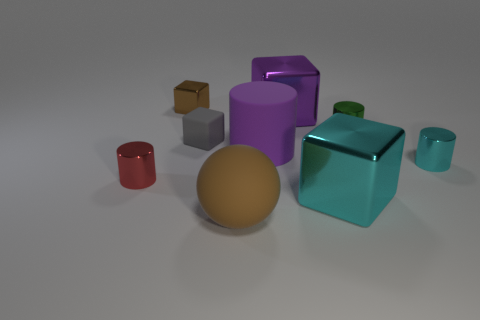Subtract all tiny brown blocks. How many blocks are left? 3 Subtract all red cylinders. How many cylinders are left? 3 Subtract 1 cylinders. How many cylinders are left? 3 Add 1 small green shiny cylinders. How many objects exist? 10 Subtract 0 brown cylinders. How many objects are left? 9 Subtract all cubes. How many objects are left? 5 Subtract all yellow cylinders. Subtract all yellow cubes. How many cylinders are left? 4 Subtract all gray balls. How many purple cylinders are left? 1 Subtract all tiny gray cubes. Subtract all gray rubber objects. How many objects are left? 7 Add 2 tiny cyan objects. How many tiny cyan objects are left? 3 